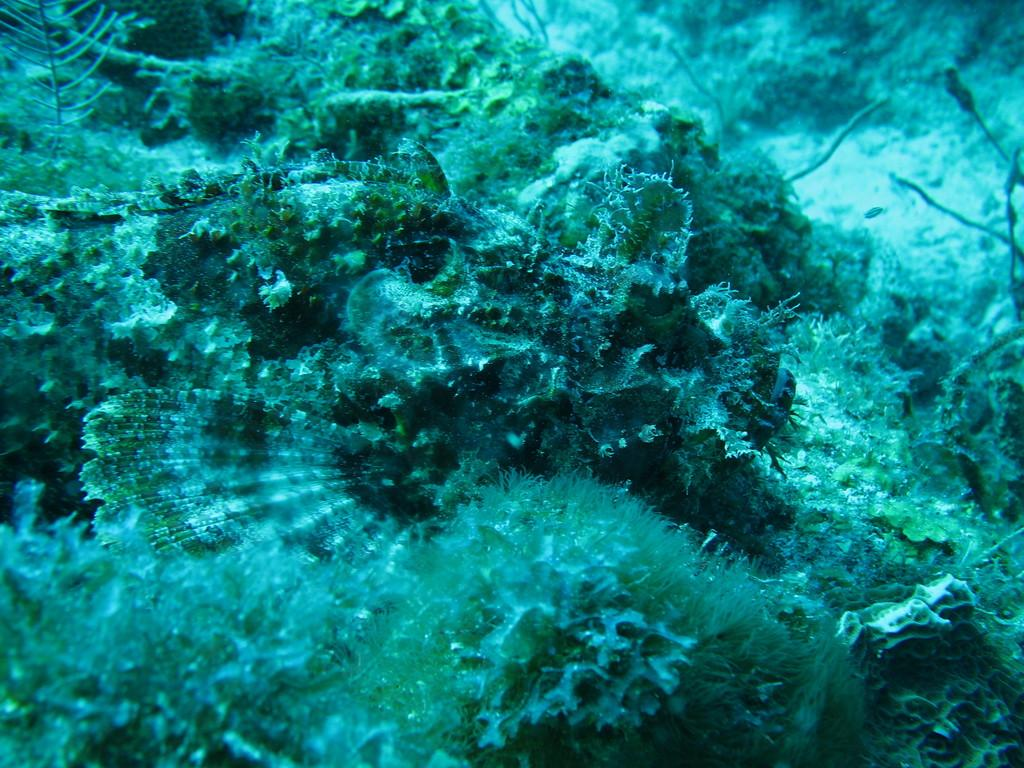What type of environment is shown in the image? The image depicts an underwater environment. Can you describe any specific features of the underwater environment? Unfortunately, the provided facts do not give any specific details about the underwater environment. What type of muscle is being used by the pencil to stretch in the image? There is no pencil or muscle present in the image, as it depicts an underwater environment. 